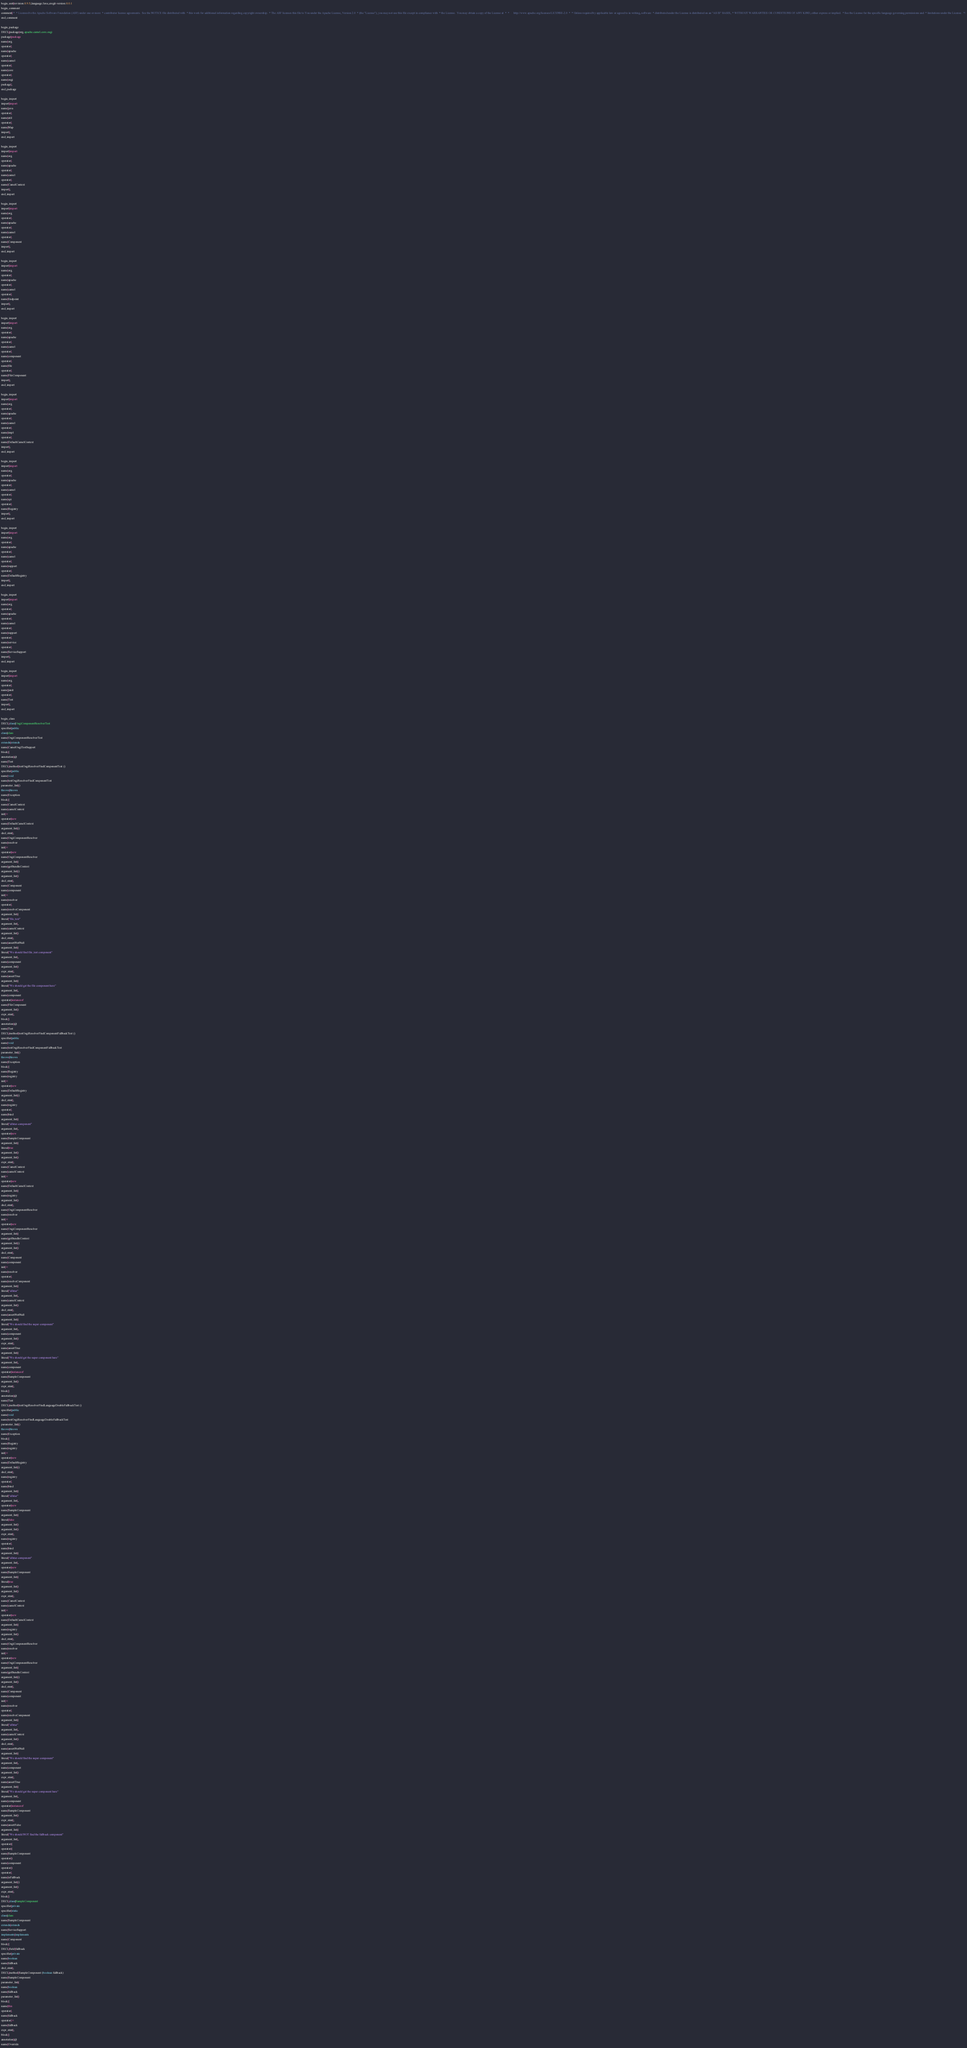<code> <loc_0><loc_0><loc_500><loc_500><_Java_>begin_unit|revision:0.9.5;language:Java;cregit-version:0.0.1
begin_comment
comment|/*  * Licensed to the Apache Software Foundation (ASF) under one or more  * contributor license agreements.  See the NOTICE file distributed with  * this work for additional information regarding copyright ownership.  * The ASF licenses this file to You under the Apache License, Version 2.0  * (the "License"); you may not use this file except in compliance with  * the License.  You may obtain a copy of the License at  *  *      http://www.apache.org/licenses/LICENSE-2.0  *  * Unless required by applicable law or agreed to in writing, software  * distributed under the License is distributed on an "AS IS" BASIS,  * WITHOUT WARRANTIES OR CONDITIONS OF ANY KIND, either express or implied.  * See the License for the specific language governing permissions and  * limitations under the License.  */
end_comment

begin_package
DECL|package|org.apache.camel.core.osgi
package|package
name|org
operator|.
name|apache
operator|.
name|camel
operator|.
name|core
operator|.
name|osgi
package|;
end_package

begin_import
import|import
name|java
operator|.
name|util
operator|.
name|Map
import|;
end_import

begin_import
import|import
name|org
operator|.
name|apache
operator|.
name|camel
operator|.
name|CamelContext
import|;
end_import

begin_import
import|import
name|org
operator|.
name|apache
operator|.
name|camel
operator|.
name|Component
import|;
end_import

begin_import
import|import
name|org
operator|.
name|apache
operator|.
name|camel
operator|.
name|Endpoint
import|;
end_import

begin_import
import|import
name|org
operator|.
name|apache
operator|.
name|camel
operator|.
name|component
operator|.
name|file
operator|.
name|FileComponent
import|;
end_import

begin_import
import|import
name|org
operator|.
name|apache
operator|.
name|camel
operator|.
name|impl
operator|.
name|DefaultCamelContext
import|;
end_import

begin_import
import|import
name|org
operator|.
name|apache
operator|.
name|camel
operator|.
name|spi
operator|.
name|Registry
import|;
end_import

begin_import
import|import
name|org
operator|.
name|apache
operator|.
name|camel
operator|.
name|support
operator|.
name|DefaultRegistry
import|;
end_import

begin_import
import|import
name|org
operator|.
name|apache
operator|.
name|camel
operator|.
name|support
operator|.
name|service
operator|.
name|ServiceSupport
import|;
end_import

begin_import
import|import
name|org
operator|.
name|junit
operator|.
name|Test
import|;
end_import

begin_class
DECL|class|OsgiComponentResolverTest
specifier|public
class|class
name|OsgiComponentResolverTest
extends|extends
name|CamelOsgiTestSupport
block|{
annotation|@
name|Test
DECL|method|testOsgiResolverFindComponentTest ()
specifier|public
name|void
name|testOsgiResolverFindComponentTest
parameter_list|()
throws|throws
name|Exception
block|{
name|CamelContext
name|camelContext
init|=
operator|new
name|DefaultCamelContext
argument_list|()
decl_stmt|;
name|OsgiComponentResolver
name|resolver
init|=
operator|new
name|OsgiComponentResolver
argument_list|(
name|getBundleContext
argument_list|()
argument_list|)
decl_stmt|;
name|Component
name|component
init|=
name|resolver
operator|.
name|resolveComponent
argument_list|(
literal|"file_test"
argument_list|,
name|camelContext
argument_list|)
decl_stmt|;
name|assertNotNull
argument_list|(
literal|"We should find file_test component"
argument_list|,
name|component
argument_list|)
expr_stmt|;
name|assertTrue
argument_list|(
literal|"We should get the file component here"
argument_list|,
name|component
operator|instanceof
name|FileComponent
argument_list|)
expr_stmt|;
block|}
annotation|@
name|Test
DECL|method|testOsgiResolverFindComponentFallbackTest ()
specifier|public
name|void
name|testOsgiResolverFindComponentFallbackTest
parameter_list|()
throws|throws
name|Exception
block|{
name|Registry
name|registry
init|=
operator|new
name|DefaultRegistry
argument_list|()
decl_stmt|;
name|registry
operator|.
name|bind
argument_list|(
literal|"allstar-component"
argument_list|,
operator|new
name|SampleComponent
argument_list|(
literal|true
argument_list|)
argument_list|)
expr_stmt|;
name|CamelContext
name|camelContext
init|=
operator|new
name|DefaultCamelContext
argument_list|(
name|registry
argument_list|)
decl_stmt|;
name|OsgiComponentResolver
name|resolver
init|=
operator|new
name|OsgiComponentResolver
argument_list|(
name|getBundleContext
argument_list|()
argument_list|)
decl_stmt|;
name|Component
name|component
init|=
name|resolver
operator|.
name|resolveComponent
argument_list|(
literal|"allstar"
argument_list|,
name|camelContext
argument_list|)
decl_stmt|;
name|assertNotNull
argument_list|(
literal|"We should find the super component"
argument_list|,
name|component
argument_list|)
expr_stmt|;
name|assertTrue
argument_list|(
literal|"We should get the super component here"
argument_list|,
name|component
operator|instanceof
name|SampleComponent
argument_list|)
expr_stmt|;
block|}
annotation|@
name|Test
DECL|method|testOsgiResolverFindLanguageDoubleFallbackTest ()
specifier|public
name|void
name|testOsgiResolverFindLanguageDoubleFallbackTest
parameter_list|()
throws|throws
name|Exception
block|{
name|Registry
name|registry
init|=
operator|new
name|DefaultRegistry
argument_list|()
decl_stmt|;
name|registry
operator|.
name|bind
argument_list|(
literal|"allstar"
argument_list|,
operator|new
name|SampleComponent
argument_list|(
literal|false
argument_list|)
argument_list|)
expr_stmt|;
name|registry
operator|.
name|bind
argument_list|(
literal|"allstar-component"
argument_list|,
operator|new
name|SampleComponent
argument_list|(
literal|true
argument_list|)
argument_list|)
expr_stmt|;
name|CamelContext
name|camelContext
init|=
operator|new
name|DefaultCamelContext
argument_list|(
name|registry
argument_list|)
decl_stmt|;
name|OsgiComponentResolver
name|resolver
init|=
operator|new
name|OsgiComponentResolver
argument_list|(
name|getBundleContext
argument_list|()
argument_list|)
decl_stmt|;
name|Component
name|component
init|=
name|resolver
operator|.
name|resolveComponent
argument_list|(
literal|"allstar"
argument_list|,
name|camelContext
argument_list|)
decl_stmt|;
name|assertNotNull
argument_list|(
literal|"We should find the super component"
argument_list|,
name|component
argument_list|)
expr_stmt|;
name|assertTrue
argument_list|(
literal|"We should get the super component here"
argument_list|,
name|component
operator|instanceof
name|SampleComponent
argument_list|)
expr_stmt|;
name|assertFalse
argument_list|(
literal|"We should NOT find the fallback component"
argument_list|,
operator|(
operator|(
name|SampleComponent
operator|)
name|component
operator|)
operator|.
name|isFallback
argument_list|()
argument_list|)
expr_stmt|;
block|}
DECL|class|SampleComponent
specifier|private
specifier|static
class|class
name|SampleComponent
extends|extends
name|ServiceSupport
implements|implements
name|Component
block|{
DECL|field|fallback
specifier|private
name|boolean
name|fallback
decl_stmt|;
DECL|method|SampleComponent (boolean fallback)
name|SampleComponent
parameter_list|(
name|boolean
name|fallback
parameter_list|)
block|{
name|this
operator|.
name|fallback
operator|=
name|fallback
expr_stmt|;
block|}
annotation|@
name|Override</code> 